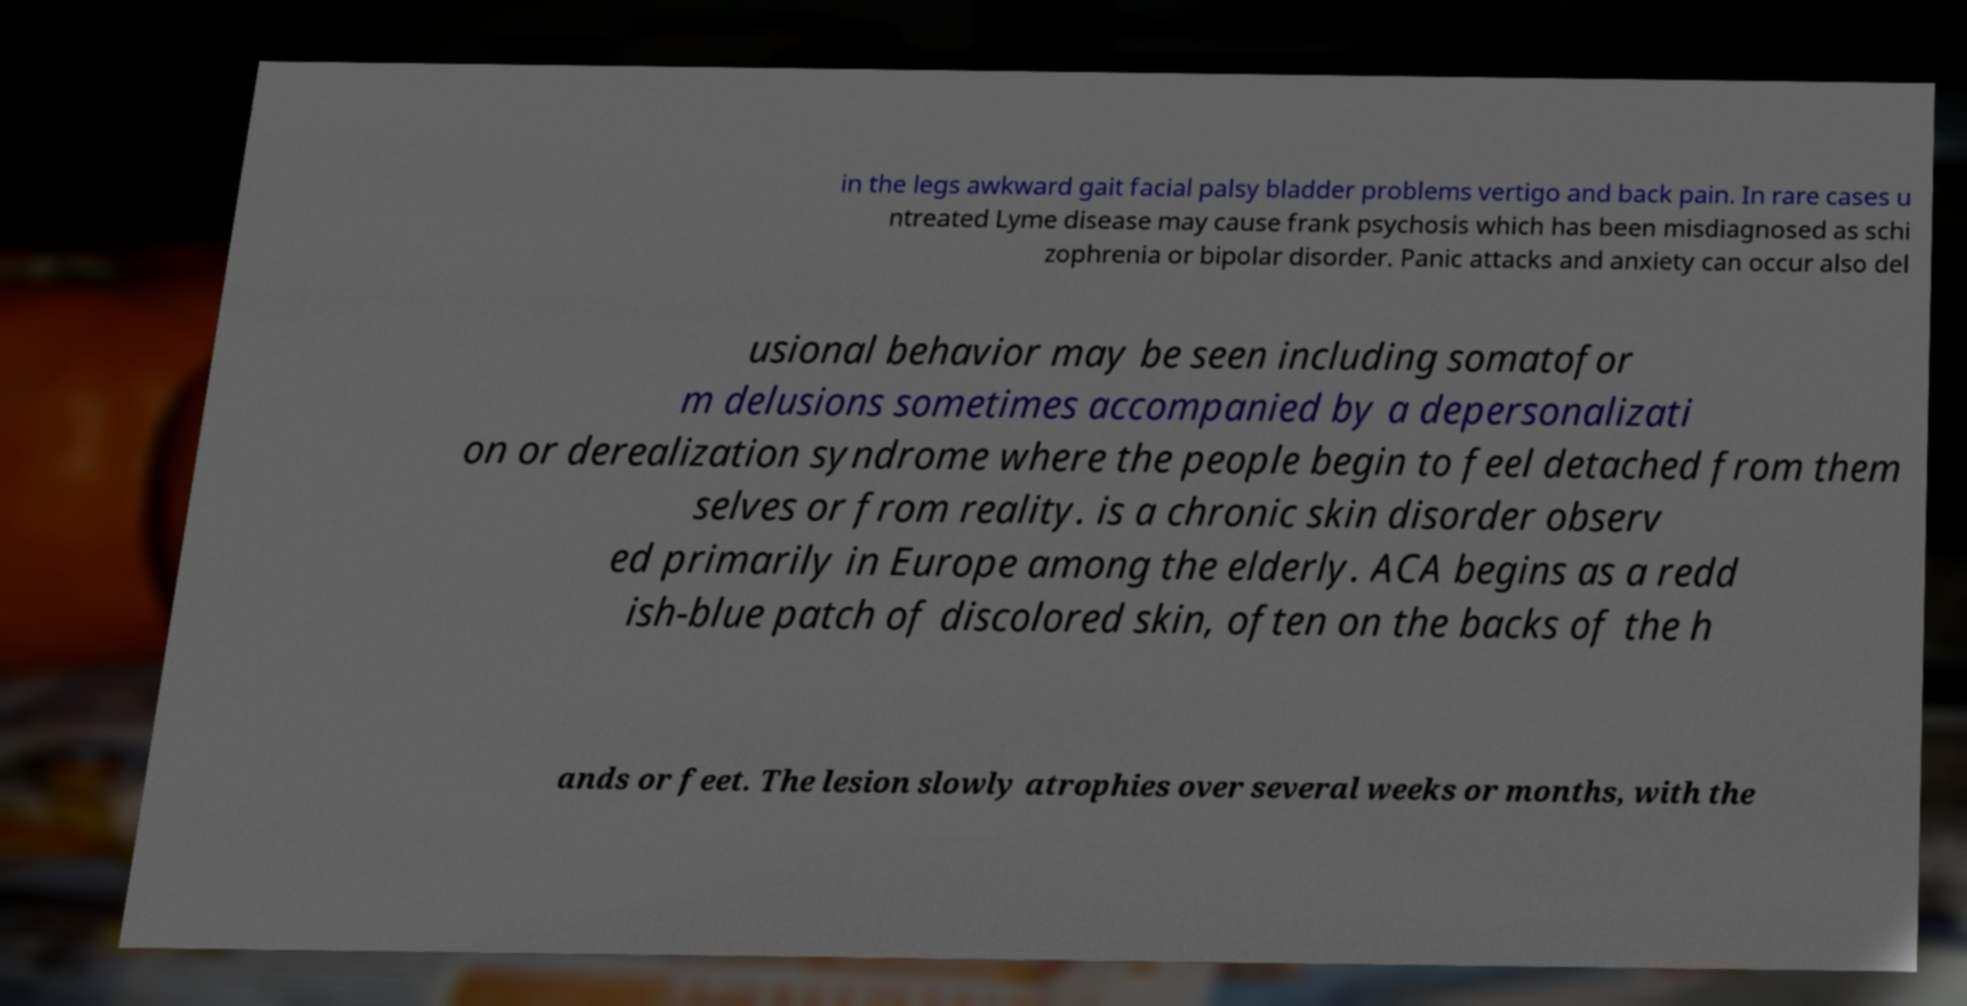Can you read and provide the text displayed in the image?This photo seems to have some interesting text. Can you extract and type it out for me? in the legs awkward gait facial palsy bladder problems vertigo and back pain. In rare cases u ntreated Lyme disease may cause frank psychosis which has been misdiagnosed as schi zophrenia or bipolar disorder. Panic attacks and anxiety can occur also del usional behavior may be seen including somatofor m delusions sometimes accompanied by a depersonalizati on or derealization syndrome where the people begin to feel detached from them selves or from reality. is a chronic skin disorder observ ed primarily in Europe among the elderly. ACA begins as a redd ish-blue patch of discolored skin, often on the backs of the h ands or feet. The lesion slowly atrophies over several weeks or months, with the 